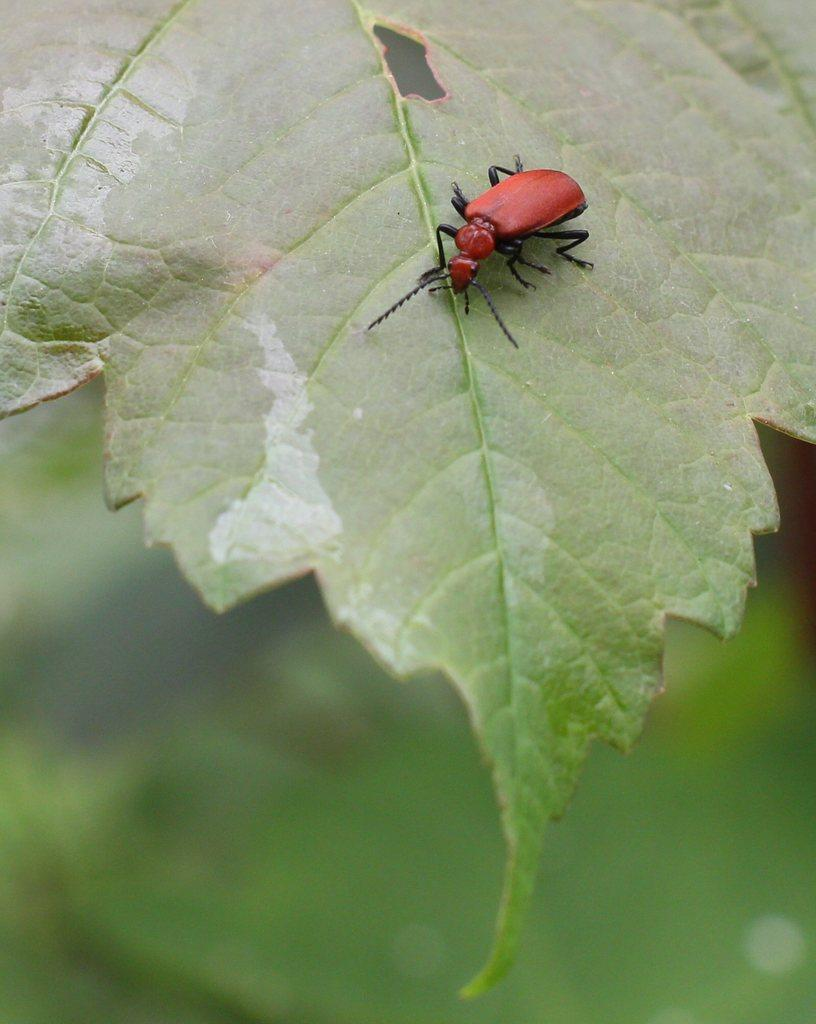What is the main subject of the picture? The main subject of the picture is an insect. Where is the insect located in the image? The insect is on a leaf. Can you describe the background of the image? The background of the image is blurred. What type of square can be seen in the image? There is no square present in the image. What pet is visible in the image? There is no pet visible in the image; it features an insect on a leaf. 